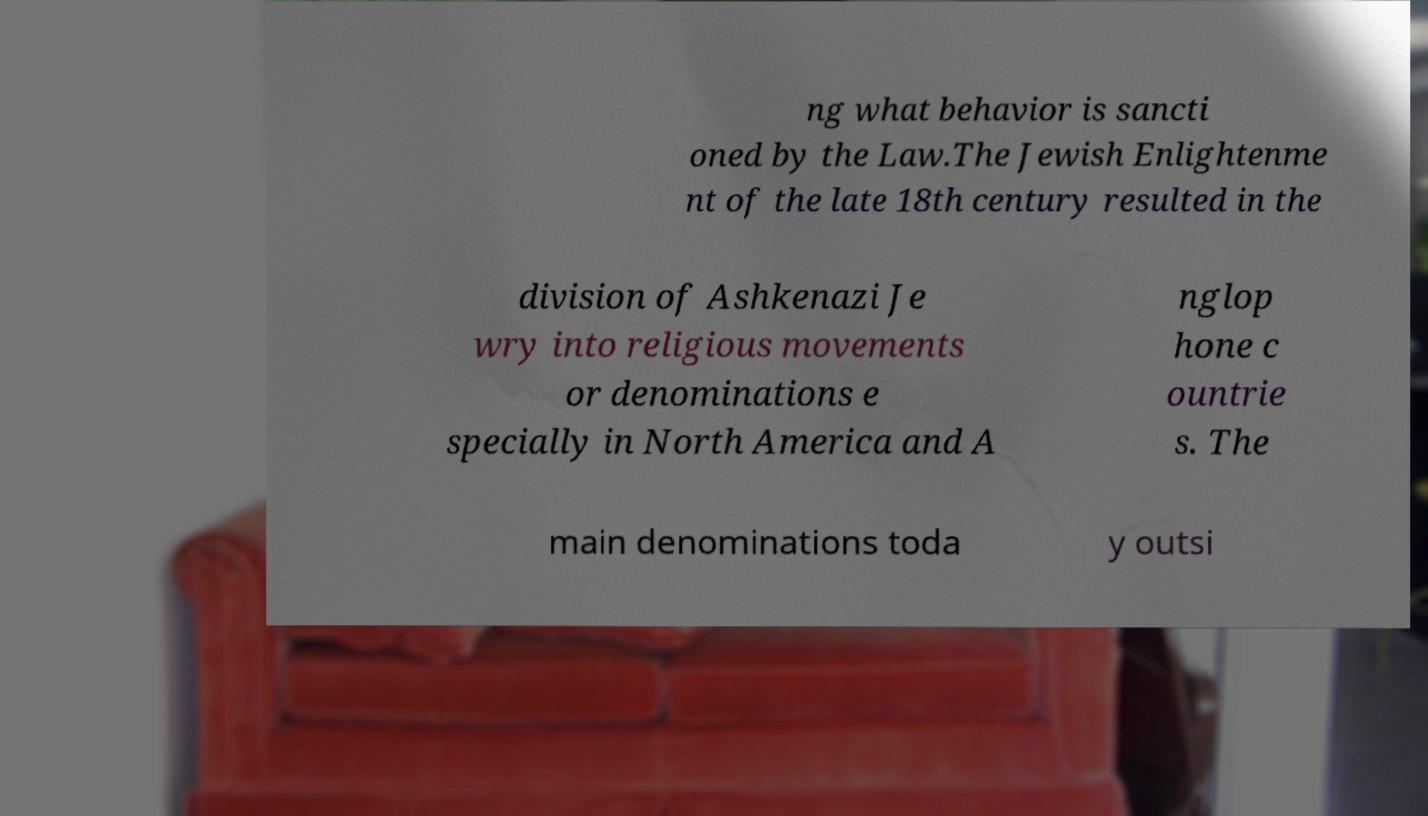I need the written content from this picture converted into text. Can you do that? ng what behavior is sancti oned by the Law.The Jewish Enlightenme nt of the late 18th century resulted in the division of Ashkenazi Je wry into religious movements or denominations e specially in North America and A nglop hone c ountrie s. The main denominations toda y outsi 